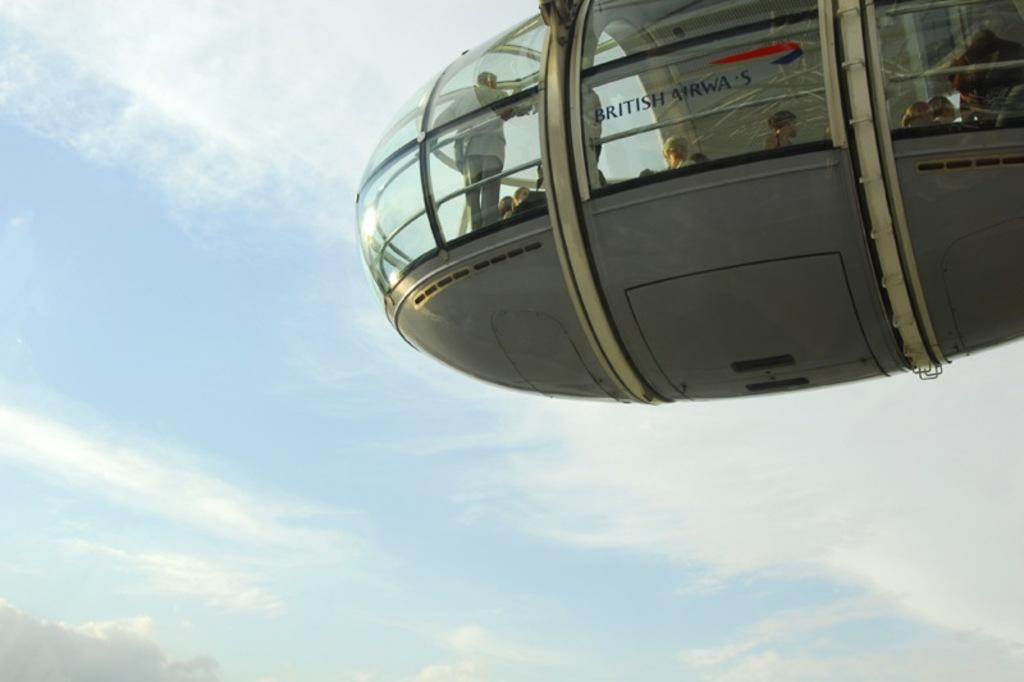What is the main subject in the foreground of the image? There is a cable car in the foreground of the image. Are there any people inside the cable car? Yes, people are inside the cable car. What can be seen in the background of the image? The sky is visible in the background of the image. What is the weather like in the image? The presence of clouds in the sky suggests that it might be partly cloudy. What type of skirt is the pest wearing in the image? There is no pest or skirt present in the image. 